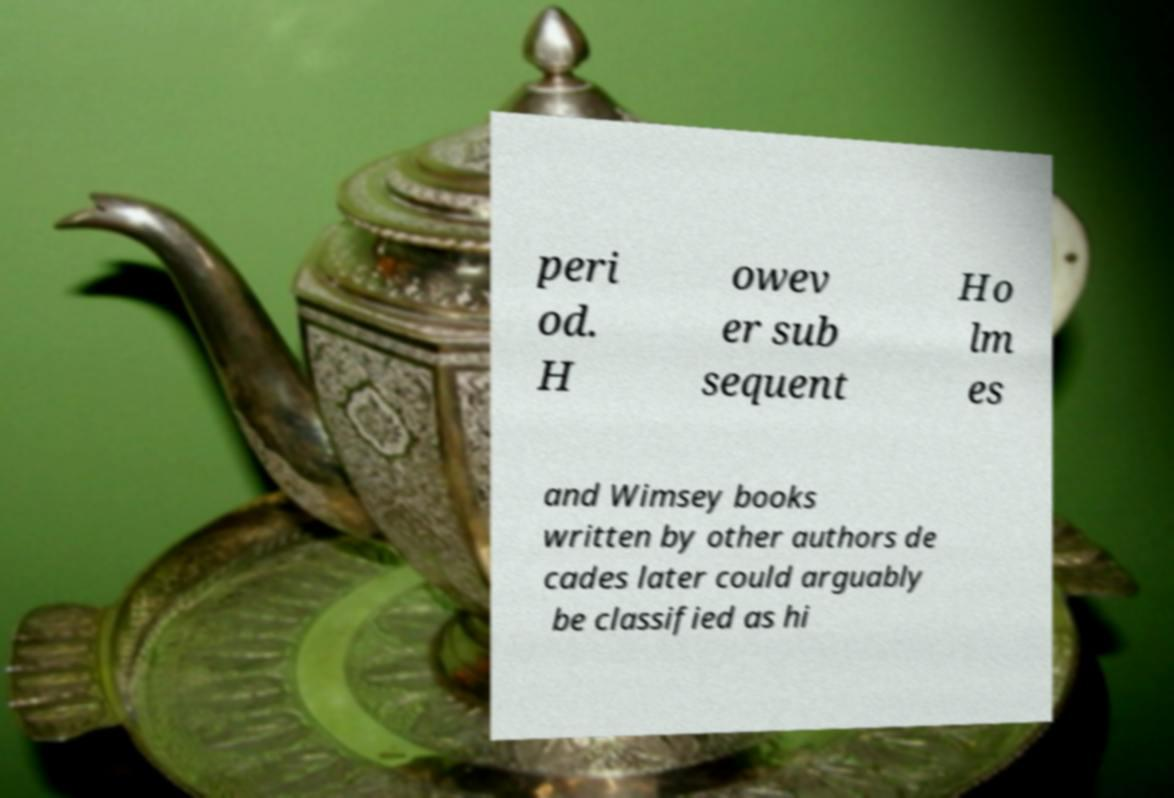Please identify and transcribe the text found in this image. peri od. H owev er sub sequent Ho lm es and Wimsey books written by other authors de cades later could arguably be classified as hi 